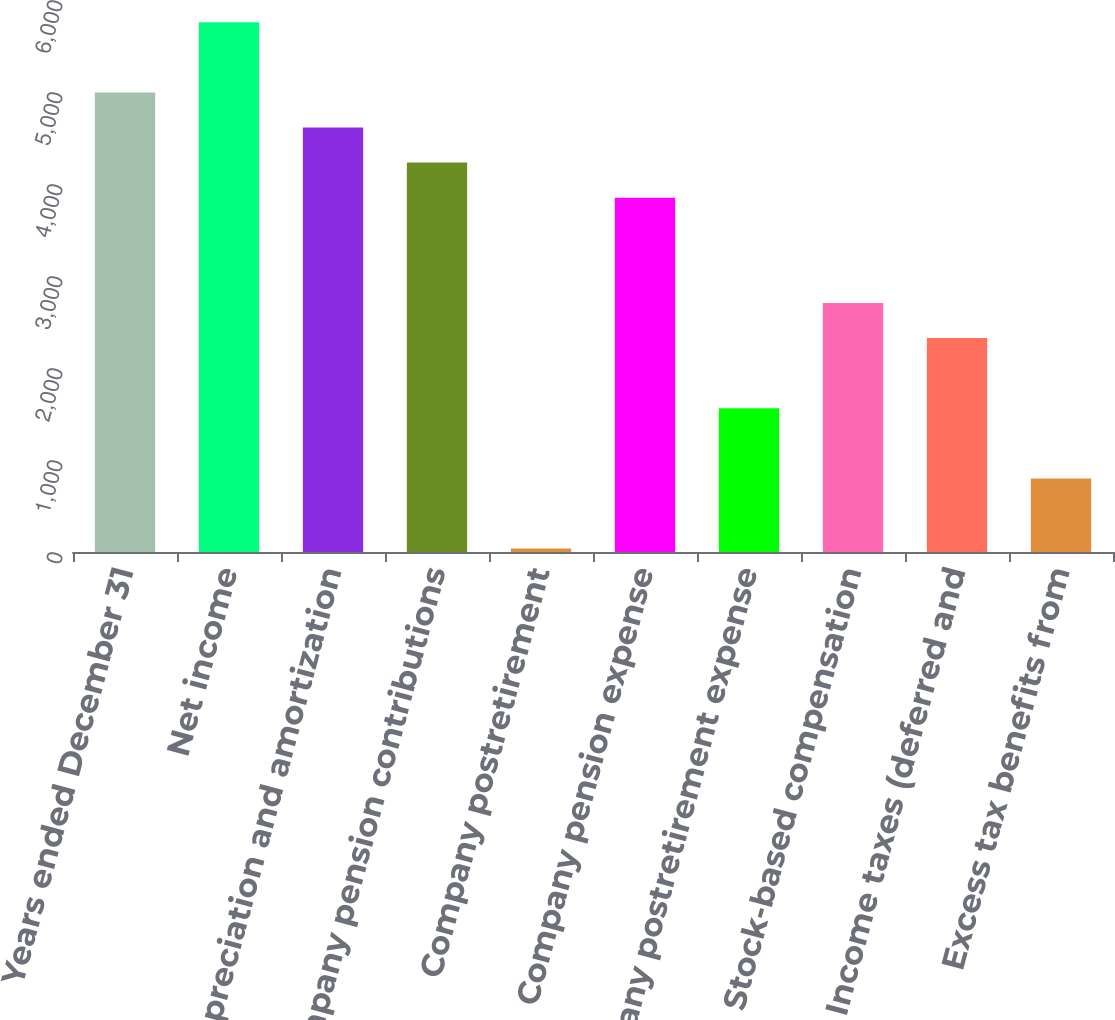Convert chart. <chart><loc_0><loc_0><loc_500><loc_500><bar_chart><fcel>Years ended December 31<fcel>Net income<fcel>Depreciation and amortization<fcel>Company pension contributions<fcel>Company postretirement<fcel>Company pension expense<fcel>Company postretirement expense<fcel>Stock-based compensation<fcel>Income taxes (deferred and<fcel>Excess tax benefits from<nl><fcel>4995.2<fcel>5758<fcel>4613.8<fcel>4232.4<fcel>37<fcel>3851<fcel>1562.6<fcel>2706.8<fcel>2325.4<fcel>799.8<nl></chart> 